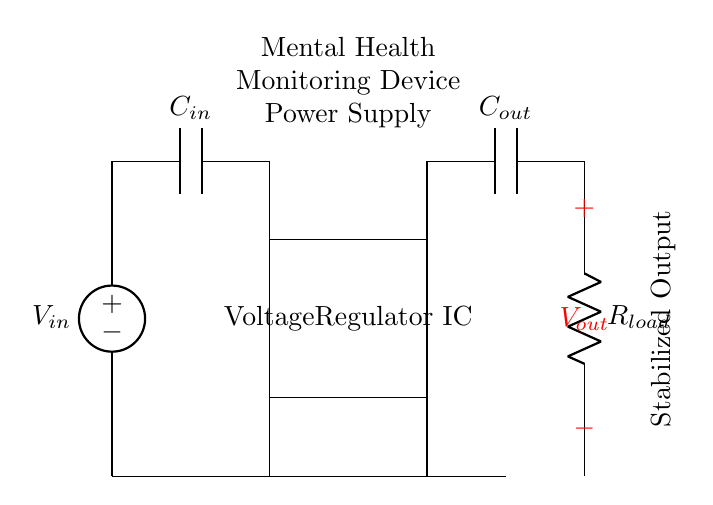What is the input voltage source? The input voltage source is labeled as V in, which represents the voltage provided to the regulator.
Answer: V in What component is used to stabilize the output voltage? The component used to stabilize the output voltage is the Voltage Regulator IC, indicated in the diagram as a rectangle labeled accordingly.
Answer: Voltage Regulator IC What are the capacitor types in this circuit? The circuit includes two capacitors: one input capacitor labeled C in and one output capacitor labeled C out.
Answer: C in, C out What does the R load represent in this circuit? The R load is a resistor representing the load on the output, illustrating the device or circuit that consumes the output power from the regulator.
Answer: Load How does the output voltage compare to the input voltage? The output voltage V out is stabilized by the regulator, generally being lower than the input voltage V in due to regulation unless specified otherwise.
Answer: Stabilized What is the purpose of the output capacitor C out? The output capacitor C out smooths and filters the output voltage, helping to stabilize the output against fluctuations in load.
Answer: Smoothing, filtering In which direction is the current likely to flow in this circuit? In a standard regulator circuit, the current flows from V in through the regulator and out through the load R load to ground.
Answer: From V in to R load 